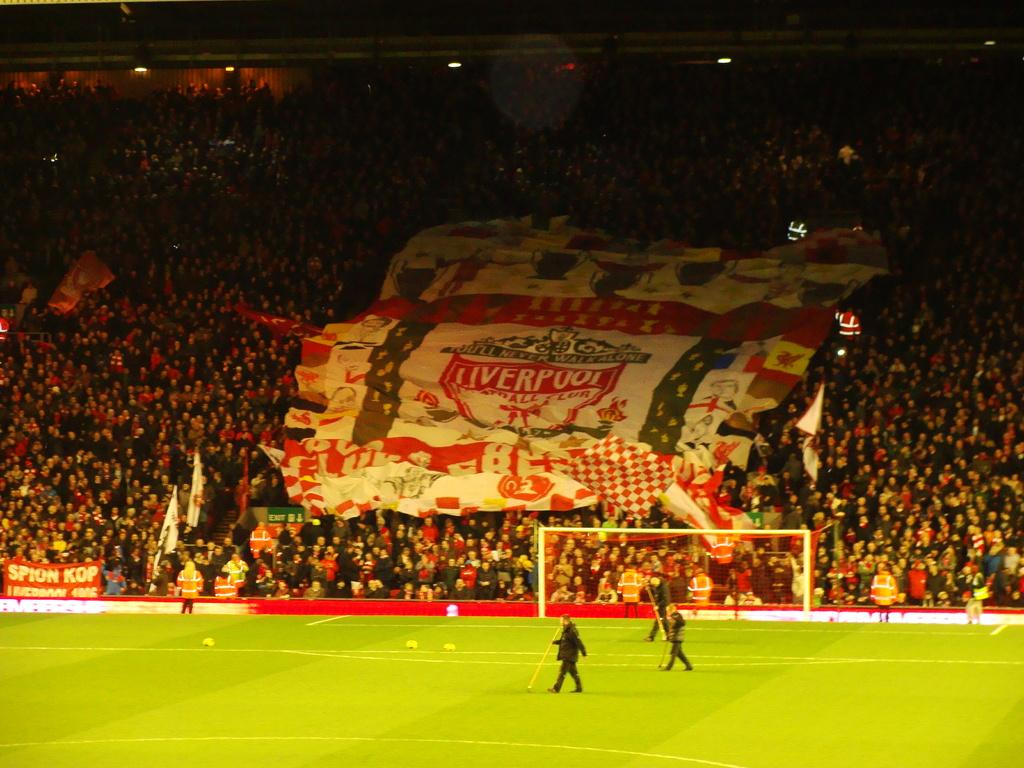<image>
Create a compact narrative representing the image presented. Fans hold up a large flag for the sports team from Liverpool. 